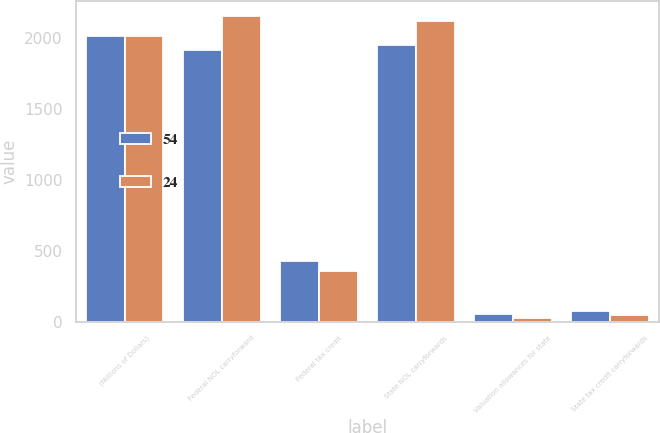Convert chart to OTSL. <chart><loc_0><loc_0><loc_500><loc_500><stacked_bar_chart><ecel><fcel>(Millions of Dollars)<fcel>Federal NOL carryforward<fcel>Federal tax credit<fcel>State NOL carryforwards<fcel>Valuation allowances for state<fcel>State tax credit carryforwards<nl><fcel>54<fcel>2016<fcel>1916<fcel>424<fcel>1949<fcel>54<fcel>74<nl><fcel>24<fcel>2015<fcel>2153<fcel>360<fcel>2124<fcel>24<fcel>45<nl></chart> 